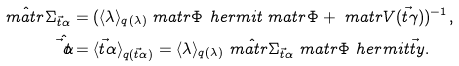<formula> <loc_0><loc_0><loc_500><loc_500>\hat { \ m a t r { \Sigma } } _ { \vec { t } { \alpha } } & = ( \langle \lambda \rangle _ { q ( \lambda ) } \ m a t r { \Phi } ^ { \ } h e r m i t \ m a t r { \Phi } + \ m a t r { V } ( \vec { t } { \gamma } ) ) ^ { - 1 } , \\ \hat { \vec { t } { \alpha } } & = \langle \vec { t } { \alpha } \rangle _ { q ( \vec { t } { \alpha } ) } = \langle \lambda \rangle _ { q ( \lambda ) } \hat { \ m a t r { \Sigma } } _ { \vec { t } { \alpha } } \ m a t r { \Phi } ^ { \ } h e r m i t \vec { t } { y } .</formula> 